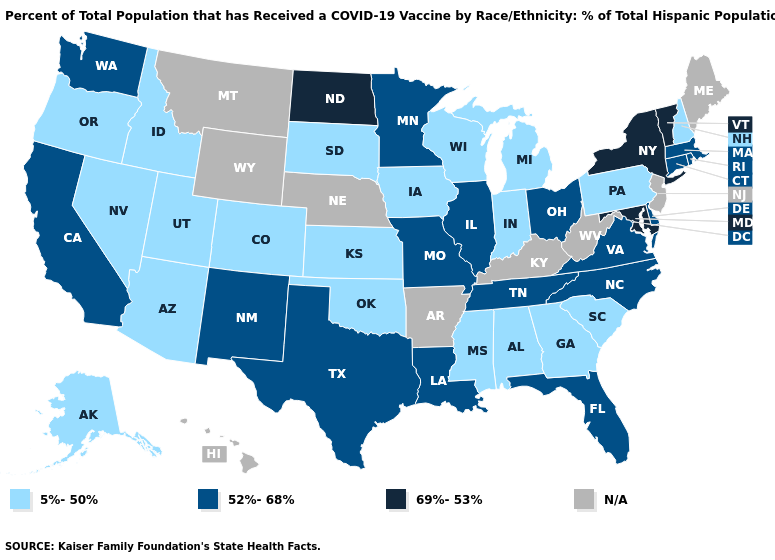Which states have the lowest value in the USA?
Quick response, please. Alabama, Alaska, Arizona, Colorado, Georgia, Idaho, Indiana, Iowa, Kansas, Michigan, Mississippi, Nevada, New Hampshire, Oklahoma, Oregon, Pennsylvania, South Carolina, South Dakota, Utah, Wisconsin. What is the lowest value in the USA?
Quick response, please. 5%-50%. Which states have the lowest value in the West?
Answer briefly. Alaska, Arizona, Colorado, Idaho, Nevada, Oregon, Utah. Among the states that border Missouri , does Oklahoma have the highest value?
Quick response, please. No. Is the legend a continuous bar?
Keep it brief. No. Does the map have missing data?
Concise answer only. Yes. What is the highest value in the USA?
Write a very short answer. 69%-53%. Name the states that have a value in the range 5%-50%?
Write a very short answer. Alabama, Alaska, Arizona, Colorado, Georgia, Idaho, Indiana, Iowa, Kansas, Michigan, Mississippi, Nevada, New Hampshire, Oklahoma, Oregon, Pennsylvania, South Carolina, South Dakota, Utah, Wisconsin. What is the highest value in the Northeast ?
Quick response, please. 69%-53%. Does the first symbol in the legend represent the smallest category?
Concise answer only. Yes. What is the value of Alaska?
Short answer required. 5%-50%. Name the states that have a value in the range 52%-68%?
Give a very brief answer. California, Connecticut, Delaware, Florida, Illinois, Louisiana, Massachusetts, Minnesota, Missouri, New Mexico, North Carolina, Ohio, Rhode Island, Tennessee, Texas, Virginia, Washington. Does the map have missing data?
Concise answer only. Yes. What is the value of Kentucky?
Answer briefly. N/A. Which states have the lowest value in the West?
Concise answer only. Alaska, Arizona, Colorado, Idaho, Nevada, Oregon, Utah. 